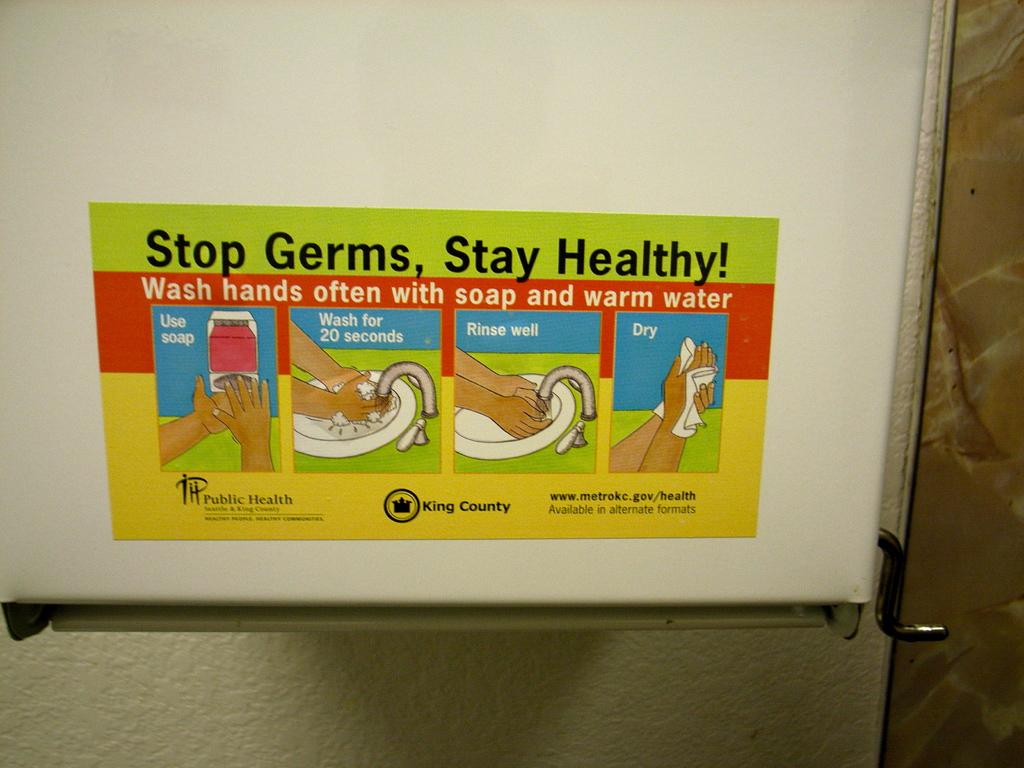Stop germs and?
Make the answer very short. Stay healthy. What is the first step?
Keep it short and to the point. Use soap. 